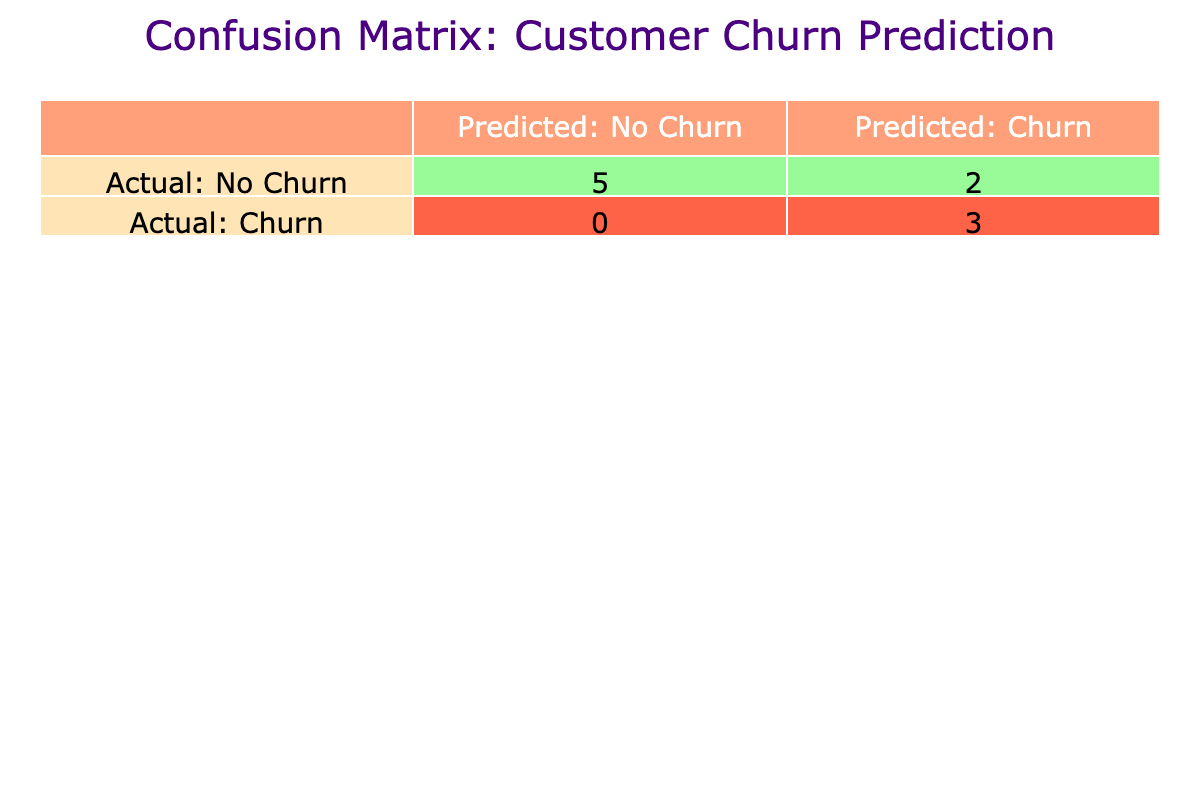What is the number of actual churned customers who were predicted to churn? From the confusion matrix, we see that the count of actual churned customers (1) predicted as churn (1) is 3.
Answer: 3 What is the total number of customers who did not churn? Referring to the table, we see that actual non-churned customers (0) are counted as 5 in the matrix.
Answer: 5 What percentage of predicted churns were actually churned? To find the percentage, we take the count of predicted churns that were correct (3) and divide by the total predicted churn count (4). Thus, (3 / 4) * 100 = 75%.
Answer: 75% Is it true that all customers who churned were predicted to churn? Checking the table, we see that there are 4 customers who actually churned, and they were all predicted to churn based on the counts in the matrix. Therefore, the statement is true.
Answer: True How many customers were misclassified as churn when they did not actually churn? From the confusion matrix, customers who did not churn but were predicted to churn (False Positive) is counted as 1.
Answer: 1 What is the ratio of actual non-churned customers to actual churned customers? The number of actual non-churned customers is 5, and the number of actual churned customers is 4. Therefore, the ratio is 5:4.
Answer: 5:4 If the model predicts that 2 out of 3 customers will churn, what does this imply about the predictive accuracy of the model? Given that the model is predicting churn correctly 3 times, it showcases a high predictive accuracy where two of those predictions are true. This indicates a strong model performance.
Answer: High predictive accuracy What is the total count of customers predicted to not churn? The confusion matrix shows that the total number of customers predicted as non-churned (0) is 6.
Answer: 6 Based on the table, are there any churned customers in the Premium subscription type? By observing the data in the matrix, we find that there are no actual churned customers (1) in the Premium category, confirming that this statement is false.
Answer: False 